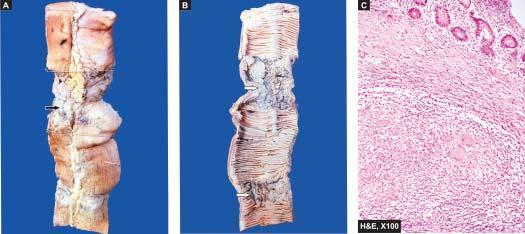what does the lumen show?
Answer the question using a single word or phrase. Characteristic transverse ulcers and two strictures 